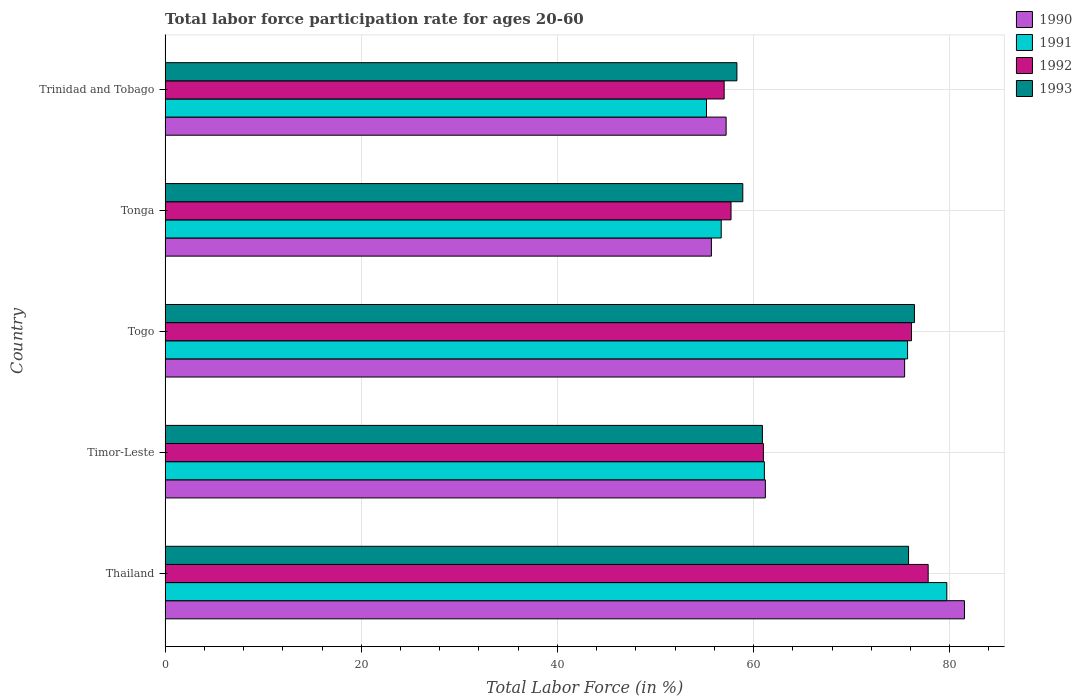Are the number of bars per tick equal to the number of legend labels?
Your response must be concise. Yes. How many bars are there on the 1st tick from the bottom?
Provide a short and direct response. 4. What is the label of the 5th group of bars from the top?
Your answer should be very brief. Thailand. In how many cases, is the number of bars for a given country not equal to the number of legend labels?
Offer a terse response. 0. What is the labor force participation rate in 1993 in Timor-Leste?
Offer a very short reply. 60.9. Across all countries, what is the maximum labor force participation rate in 1992?
Your answer should be very brief. 77.8. Across all countries, what is the minimum labor force participation rate in 1993?
Provide a short and direct response. 58.3. In which country was the labor force participation rate in 1990 maximum?
Your answer should be compact. Thailand. In which country was the labor force participation rate in 1992 minimum?
Your answer should be compact. Trinidad and Tobago. What is the total labor force participation rate in 1992 in the graph?
Provide a short and direct response. 329.6. What is the difference between the labor force participation rate in 1993 in Togo and that in Tonga?
Provide a succinct answer. 17.5. What is the difference between the labor force participation rate in 1992 in Tonga and the labor force participation rate in 1990 in Thailand?
Offer a very short reply. -23.8. What is the average labor force participation rate in 1992 per country?
Provide a short and direct response. 65.92. What is the difference between the labor force participation rate in 1993 and labor force participation rate in 1991 in Tonga?
Your answer should be compact. 2.2. What is the ratio of the labor force participation rate in 1991 in Thailand to that in Trinidad and Tobago?
Make the answer very short. 1.44. Is the difference between the labor force participation rate in 1993 in Timor-Leste and Tonga greater than the difference between the labor force participation rate in 1991 in Timor-Leste and Tonga?
Your response must be concise. No. What is the difference between the highest and the second highest labor force participation rate in 1990?
Offer a terse response. 6.1. What is the difference between the highest and the lowest labor force participation rate in 1990?
Offer a terse response. 25.8. In how many countries, is the labor force participation rate in 1991 greater than the average labor force participation rate in 1991 taken over all countries?
Offer a very short reply. 2. Is it the case that in every country, the sum of the labor force participation rate in 1991 and labor force participation rate in 1993 is greater than the sum of labor force participation rate in 1990 and labor force participation rate in 1992?
Give a very brief answer. No. What does the 2nd bar from the bottom in Timor-Leste represents?
Offer a very short reply. 1991. Is it the case that in every country, the sum of the labor force participation rate in 1990 and labor force participation rate in 1993 is greater than the labor force participation rate in 1991?
Offer a very short reply. Yes. Does the graph contain any zero values?
Ensure brevity in your answer.  No. Does the graph contain grids?
Offer a very short reply. Yes. Where does the legend appear in the graph?
Give a very brief answer. Top right. What is the title of the graph?
Your answer should be compact. Total labor force participation rate for ages 20-60. Does "1974" appear as one of the legend labels in the graph?
Your answer should be compact. No. What is the label or title of the X-axis?
Keep it short and to the point. Total Labor Force (in %). What is the label or title of the Y-axis?
Provide a succinct answer. Country. What is the Total Labor Force (in %) in 1990 in Thailand?
Provide a short and direct response. 81.5. What is the Total Labor Force (in %) of 1991 in Thailand?
Offer a terse response. 79.7. What is the Total Labor Force (in %) in 1992 in Thailand?
Your response must be concise. 77.8. What is the Total Labor Force (in %) of 1993 in Thailand?
Your answer should be compact. 75.8. What is the Total Labor Force (in %) in 1990 in Timor-Leste?
Provide a short and direct response. 61.2. What is the Total Labor Force (in %) in 1991 in Timor-Leste?
Your answer should be compact. 61.1. What is the Total Labor Force (in %) in 1993 in Timor-Leste?
Keep it short and to the point. 60.9. What is the Total Labor Force (in %) in 1990 in Togo?
Provide a short and direct response. 75.4. What is the Total Labor Force (in %) in 1991 in Togo?
Ensure brevity in your answer.  75.7. What is the Total Labor Force (in %) of 1992 in Togo?
Your answer should be very brief. 76.1. What is the Total Labor Force (in %) in 1993 in Togo?
Provide a succinct answer. 76.4. What is the Total Labor Force (in %) in 1990 in Tonga?
Your answer should be compact. 55.7. What is the Total Labor Force (in %) of 1991 in Tonga?
Offer a terse response. 56.7. What is the Total Labor Force (in %) in 1992 in Tonga?
Make the answer very short. 57.7. What is the Total Labor Force (in %) of 1993 in Tonga?
Your answer should be compact. 58.9. What is the Total Labor Force (in %) of 1990 in Trinidad and Tobago?
Ensure brevity in your answer.  57.2. What is the Total Labor Force (in %) in 1991 in Trinidad and Tobago?
Your answer should be compact. 55.2. What is the Total Labor Force (in %) of 1992 in Trinidad and Tobago?
Ensure brevity in your answer.  57. What is the Total Labor Force (in %) of 1993 in Trinidad and Tobago?
Provide a succinct answer. 58.3. Across all countries, what is the maximum Total Labor Force (in %) in 1990?
Make the answer very short. 81.5. Across all countries, what is the maximum Total Labor Force (in %) in 1991?
Make the answer very short. 79.7. Across all countries, what is the maximum Total Labor Force (in %) of 1992?
Your answer should be compact. 77.8. Across all countries, what is the maximum Total Labor Force (in %) of 1993?
Make the answer very short. 76.4. Across all countries, what is the minimum Total Labor Force (in %) in 1990?
Offer a very short reply. 55.7. Across all countries, what is the minimum Total Labor Force (in %) in 1991?
Your response must be concise. 55.2. Across all countries, what is the minimum Total Labor Force (in %) of 1992?
Your answer should be very brief. 57. Across all countries, what is the minimum Total Labor Force (in %) in 1993?
Provide a short and direct response. 58.3. What is the total Total Labor Force (in %) in 1990 in the graph?
Your answer should be very brief. 331. What is the total Total Labor Force (in %) in 1991 in the graph?
Offer a terse response. 328.4. What is the total Total Labor Force (in %) in 1992 in the graph?
Keep it short and to the point. 329.6. What is the total Total Labor Force (in %) in 1993 in the graph?
Offer a terse response. 330.3. What is the difference between the Total Labor Force (in %) of 1990 in Thailand and that in Timor-Leste?
Provide a short and direct response. 20.3. What is the difference between the Total Labor Force (in %) in 1992 in Thailand and that in Timor-Leste?
Provide a short and direct response. 16.8. What is the difference between the Total Labor Force (in %) in 1993 in Thailand and that in Timor-Leste?
Make the answer very short. 14.9. What is the difference between the Total Labor Force (in %) of 1990 in Thailand and that in Togo?
Your answer should be very brief. 6.1. What is the difference between the Total Labor Force (in %) of 1991 in Thailand and that in Togo?
Give a very brief answer. 4. What is the difference between the Total Labor Force (in %) of 1992 in Thailand and that in Togo?
Your response must be concise. 1.7. What is the difference between the Total Labor Force (in %) in 1990 in Thailand and that in Tonga?
Your answer should be compact. 25.8. What is the difference between the Total Labor Force (in %) of 1991 in Thailand and that in Tonga?
Your answer should be very brief. 23. What is the difference between the Total Labor Force (in %) of 1992 in Thailand and that in Tonga?
Ensure brevity in your answer.  20.1. What is the difference between the Total Labor Force (in %) in 1990 in Thailand and that in Trinidad and Tobago?
Your response must be concise. 24.3. What is the difference between the Total Labor Force (in %) of 1991 in Thailand and that in Trinidad and Tobago?
Your answer should be compact. 24.5. What is the difference between the Total Labor Force (in %) in 1992 in Thailand and that in Trinidad and Tobago?
Keep it short and to the point. 20.8. What is the difference between the Total Labor Force (in %) of 1990 in Timor-Leste and that in Togo?
Your answer should be compact. -14.2. What is the difference between the Total Labor Force (in %) of 1991 in Timor-Leste and that in Togo?
Your answer should be very brief. -14.6. What is the difference between the Total Labor Force (in %) of 1992 in Timor-Leste and that in Togo?
Your response must be concise. -15.1. What is the difference between the Total Labor Force (in %) in 1993 in Timor-Leste and that in Togo?
Your answer should be very brief. -15.5. What is the difference between the Total Labor Force (in %) of 1991 in Timor-Leste and that in Tonga?
Offer a terse response. 4.4. What is the difference between the Total Labor Force (in %) of 1990 in Timor-Leste and that in Trinidad and Tobago?
Provide a short and direct response. 4. What is the difference between the Total Labor Force (in %) of 1990 in Togo and that in Tonga?
Offer a terse response. 19.7. What is the difference between the Total Labor Force (in %) of 1990 in Togo and that in Trinidad and Tobago?
Keep it short and to the point. 18.2. What is the difference between the Total Labor Force (in %) in 1990 in Thailand and the Total Labor Force (in %) in 1991 in Timor-Leste?
Offer a terse response. 20.4. What is the difference between the Total Labor Force (in %) of 1990 in Thailand and the Total Labor Force (in %) of 1992 in Timor-Leste?
Offer a very short reply. 20.5. What is the difference between the Total Labor Force (in %) in 1990 in Thailand and the Total Labor Force (in %) in 1993 in Timor-Leste?
Your answer should be very brief. 20.6. What is the difference between the Total Labor Force (in %) of 1991 in Thailand and the Total Labor Force (in %) of 1992 in Timor-Leste?
Make the answer very short. 18.7. What is the difference between the Total Labor Force (in %) of 1990 in Thailand and the Total Labor Force (in %) of 1992 in Togo?
Make the answer very short. 5.4. What is the difference between the Total Labor Force (in %) of 1991 in Thailand and the Total Labor Force (in %) of 1992 in Togo?
Your answer should be very brief. 3.6. What is the difference between the Total Labor Force (in %) in 1991 in Thailand and the Total Labor Force (in %) in 1993 in Togo?
Offer a terse response. 3.3. What is the difference between the Total Labor Force (in %) in 1992 in Thailand and the Total Labor Force (in %) in 1993 in Togo?
Offer a terse response. 1.4. What is the difference between the Total Labor Force (in %) of 1990 in Thailand and the Total Labor Force (in %) of 1991 in Tonga?
Provide a short and direct response. 24.8. What is the difference between the Total Labor Force (in %) in 1990 in Thailand and the Total Labor Force (in %) in 1992 in Tonga?
Offer a very short reply. 23.8. What is the difference between the Total Labor Force (in %) of 1990 in Thailand and the Total Labor Force (in %) of 1993 in Tonga?
Give a very brief answer. 22.6. What is the difference between the Total Labor Force (in %) in 1991 in Thailand and the Total Labor Force (in %) in 1992 in Tonga?
Ensure brevity in your answer.  22. What is the difference between the Total Labor Force (in %) of 1991 in Thailand and the Total Labor Force (in %) of 1993 in Tonga?
Your answer should be compact. 20.8. What is the difference between the Total Labor Force (in %) of 1992 in Thailand and the Total Labor Force (in %) of 1993 in Tonga?
Your answer should be compact. 18.9. What is the difference between the Total Labor Force (in %) of 1990 in Thailand and the Total Labor Force (in %) of 1991 in Trinidad and Tobago?
Provide a short and direct response. 26.3. What is the difference between the Total Labor Force (in %) in 1990 in Thailand and the Total Labor Force (in %) in 1992 in Trinidad and Tobago?
Offer a terse response. 24.5. What is the difference between the Total Labor Force (in %) of 1990 in Thailand and the Total Labor Force (in %) of 1993 in Trinidad and Tobago?
Your response must be concise. 23.2. What is the difference between the Total Labor Force (in %) in 1991 in Thailand and the Total Labor Force (in %) in 1992 in Trinidad and Tobago?
Your answer should be very brief. 22.7. What is the difference between the Total Labor Force (in %) of 1991 in Thailand and the Total Labor Force (in %) of 1993 in Trinidad and Tobago?
Provide a succinct answer. 21.4. What is the difference between the Total Labor Force (in %) of 1990 in Timor-Leste and the Total Labor Force (in %) of 1991 in Togo?
Offer a very short reply. -14.5. What is the difference between the Total Labor Force (in %) of 1990 in Timor-Leste and the Total Labor Force (in %) of 1992 in Togo?
Your answer should be compact. -14.9. What is the difference between the Total Labor Force (in %) in 1990 in Timor-Leste and the Total Labor Force (in %) in 1993 in Togo?
Keep it short and to the point. -15.2. What is the difference between the Total Labor Force (in %) of 1991 in Timor-Leste and the Total Labor Force (in %) of 1993 in Togo?
Provide a short and direct response. -15.3. What is the difference between the Total Labor Force (in %) of 1992 in Timor-Leste and the Total Labor Force (in %) of 1993 in Togo?
Your answer should be compact. -15.4. What is the difference between the Total Labor Force (in %) of 1990 in Timor-Leste and the Total Labor Force (in %) of 1992 in Tonga?
Offer a very short reply. 3.5. What is the difference between the Total Labor Force (in %) in 1991 in Timor-Leste and the Total Labor Force (in %) in 1992 in Tonga?
Offer a very short reply. 3.4. What is the difference between the Total Labor Force (in %) of 1991 in Timor-Leste and the Total Labor Force (in %) of 1993 in Tonga?
Ensure brevity in your answer.  2.2. What is the difference between the Total Labor Force (in %) in 1990 in Timor-Leste and the Total Labor Force (in %) in 1992 in Trinidad and Tobago?
Make the answer very short. 4.2. What is the difference between the Total Labor Force (in %) in 1992 in Timor-Leste and the Total Labor Force (in %) in 1993 in Trinidad and Tobago?
Keep it short and to the point. 2.7. What is the difference between the Total Labor Force (in %) of 1990 in Togo and the Total Labor Force (in %) of 1993 in Tonga?
Give a very brief answer. 16.5. What is the difference between the Total Labor Force (in %) in 1991 in Togo and the Total Labor Force (in %) in 1993 in Tonga?
Give a very brief answer. 16.8. What is the difference between the Total Labor Force (in %) in 1992 in Togo and the Total Labor Force (in %) in 1993 in Tonga?
Your answer should be compact. 17.2. What is the difference between the Total Labor Force (in %) of 1990 in Togo and the Total Labor Force (in %) of 1991 in Trinidad and Tobago?
Offer a very short reply. 20.2. What is the difference between the Total Labor Force (in %) of 1990 in Togo and the Total Labor Force (in %) of 1992 in Trinidad and Tobago?
Your answer should be very brief. 18.4. What is the difference between the Total Labor Force (in %) in 1991 in Togo and the Total Labor Force (in %) in 1993 in Trinidad and Tobago?
Your answer should be compact. 17.4. What is the difference between the Total Labor Force (in %) of 1990 in Tonga and the Total Labor Force (in %) of 1991 in Trinidad and Tobago?
Your response must be concise. 0.5. What is the difference between the Total Labor Force (in %) of 1991 in Tonga and the Total Labor Force (in %) of 1992 in Trinidad and Tobago?
Keep it short and to the point. -0.3. What is the difference between the Total Labor Force (in %) of 1991 in Tonga and the Total Labor Force (in %) of 1993 in Trinidad and Tobago?
Your answer should be very brief. -1.6. What is the difference between the Total Labor Force (in %) of 1992 in Tonga and the Total Labor Force (in %) of 1993 in Trinidad and Tobago?
Keep it short and to the point. -0.6. What is the average Total Labor Force (in %) of 1990 per country?
Your response must be concise. 66.2. What is the average Total Labor Force (in %) in 1991 per country?
Keep it short and to the point. 65.68. What is the average Total Labor Force (in %) of 1992 per country?
Provide a short and direct response. 65.92. What is the average Total Labor Force (in %) in 1993 per country?
Provide a succinct answer. 66.06. What is the difference between the Total Labor Force (in %) of 1990 and Total Labor Force (in %) of 1992 in Thailand?
Offer a very short reply. 3.7. What is the difference between the Total Labor Force (in %) of 1991 and Total Labor Force (in %) of 1993 in Thailand?
Provide a succinct answer. 3.9. What is the difference between the Total Labor Force (in %) in 1992 and Total Labor Force (in %) in 1993 in Thailand?
Your answer should be very brief. 2. What is the difference between the Total Labor Force (in %) in 1990 and Total Labor Force (in %) in 1991 in Timor-Leste?
Your response must be concise. 0.1. What is the difference between the Total Labor Force (in %) in 1990 and Total Labor Force (in %) in 1993 in Timor-Leste?
Offer a very short reply. 0.3. What is the difference between the Total Labor Force (in %) of 1991 and Total Labor Force (in %) of 1992 in Timor-Leste?
Your response must be concise. 0.1. What is the difference between the Total Labor Force (in %) of 1991 and Total Labor Force (in %) of 1993 in Timor-Leste?
Your answer should be very brief. 0.2. What is the difference between the Total Labor Force (in %) in 1992 and Total Labor Force (in %) in 1993 in Timor-Leste?
Your answer should be compact. 0.1. What is the difference between the Total Labor Force (in %) in 1990 and Total Labor Force (in %) in 1992 in Togo?
Provide a short and direct response. -0.7. What is the difference between the Total Labor Force (in %) in 1990 and Total Labor Force (in %) in 1993 in Togo?
Offer a terse response. -1. What is the difference between the Total Labor Force (in %) in 1991 and Total Labor Force (in %) in 1993 in Togo?
Offer a very short reply. -0.7. What is the difference between the Total Labor Force (in %) of 1990 and Total Labor Force (in %) of 1991 in Tonga?
Make the answer very short. -1. What is the difference between the Total Labor Force (in %) in 1990 and Total Labor Force (in %) in 1992 in Tonga?
Keep it short and to the point. -2. What is the difference between the Total Labor Force (in %) in 1990 and Total Labor Force (in %) in 1993 in Tonga?
Your answer should be very brief. -3.2. What is the difference between the Total Labor Force (in %) in 1990 and Total Labor Force (in %) in 1991 in Trinidad and Tobago?
Ensure brevity in your answer.  2. What is the difference between the Total Labor Force (in %) of 1990 and Total Labor Force (in %) of 1992 in Trinidad and Tobago?
Provide a succinct answer. 0.2. What is the difference between the Total Labor Force (in %) in 1990 and Total Labor Force (in %) in 1993 in Trinidad and Tobago?
Give a very brief answer. -1.1. What is the difference between the Total Labor Force (in %) in 1991 and Total Labor Force (in %) in 1992 in Trinidad and Tobago?
Make the answer very short. -1.8. What is the difference between the Total Labor Force (in %) in 1992 and Total Labor Force (in %) in 1993 in Trinidad and Tobago?
Your answer should be compact. -1.3. What is the ratio of the Total Labor Force (in %) of 1990 in Thailand to that in Timor-Leste?
Your response must be concise. 1.33. What is the ratio of the Total Labor Force (in %) of 1991 in Thailand to that in Timor-Leste?
Provide a short and direct response. 1.3. What is the ratio of the Total Labor Force (in %) of 1992 in Thailand to that in Timor-Leste?
Make the answer very short. 1.28. What is the ratio of the Total Labor Force (in %) in 1993 in Thailand to that in Timor-Leste?
Your answer should be compact. 1.24. What is the ratio of the Total Labor Force (in %) in 1990 in Thailand to that in Togo?
Provide a succinct answer. 1.08. What is the ratio of the Total Labor Force (in %) of 1991 in Thailand to that in Togo?
Make the answer very short. 1.05. What is the ratio of the Total Labor Force (in %) of 1992 in Thailand to that in Togo?
Your answer should be very brief. 1.02. What is the ratio of the Total Labor Force (in %) in 1990 in Thailand to that in Tonga?
Offer a very short reply. 1.46. What is the ratio of the Total Labor Force (in %) of 1991 in Thailand to that in Tonga?
Keep it short and to the point. 1.41. What is the ratio of the Total Labor Force (in %) in 1992 in Thailand to that in Tonga?
Give a very brief answer. 1.35. What is the ratio of the Total Labor Force (in %) of 1993 in Thailand to that in Tonga?
Make the answer very short. 1.29. What is the ratio of the Total Labor Force (in %) of 1990 in Thailand to that in Trinidad and Tobago?
Offer a terse response. 1.42. What is the ratio of the Total Labor Force (in %) of 1991 in Thailand to that in Trinidad and Tobago?
Offer a terse response. 1.44. What is the ratio of the Total Labor Force (in %) in 1992 in Thailand to that in Trinidad and Tobago?
Offer a terse response. 1.36. What is the ratio of the Total Labor Force (in %) in 1993 in Thailand to that in Trinidad and Tobago?
Your response must be concise. 1.3. What is the ratio of the Total Labor Force (in %) in 1990 in Timor-Leste to that in Togo?
Make the answer very short. 0.81. What is the ratio of the Total Labor Force (in %) in 1991 in Timor-Leste to that in Togo?
Make the answer very short. 0.81. What is the ratio of the Total Labor Force (in %) in 1992 in Timor-Leste to that in Togo?
Your answer should be very brief. 0.8. What is the ratio of the Total Labor Force (in %) in 1993 in Timor-Leste to that in Togo?
Offer a terse response. 0.8. What is the ratio of the Total Labor Force (in %) in 1990 in Timor-Leste to that in Tonga?
Ensure brevity in your answer.  1.1. What is the ratio of the Total Labor Force (in %) in 1991 in Timor-Leste to that in Tonga?
Provide a succinct answer. 1.08. What is the ratio of the Total Labor Force (in %) of 1992 in Timor-Leste to that in Tonga?
Provide a short and direct response. 1.06. What is the ratio of the Total Labor Force (in %) in 1993 in Timor-Leste to that in Tonga?
Provide a short and direct response. 1.03. What is the ratio of the Total Labor Force (in %) in 1990 in Timor-Leste to that in Trinidad and Tobago?
Make the answer very short. 1.07. What is the ratio of the Total Labor Force (in %) of 1991 in Timor-Leste to that in Trinidad and Tobago?
Your response must be concise. 1.11. What is the ratio of the Total Labor Force (in %) of 1992 in Timor-Leste to that in Trinidad and Tobago?
Your answer should be compact. 1.07. What is the ratio of the Total Labor Force (in %) in 1993 in Timor-Leste to that in Trinidad and Tobago?
Offer a terse response. 1.04. What is the ratio of the Total Labor Force (in %) in 1990 in Togo to that in Tonga?
Ensure brevity in your answer.  1.35. What is the ratio of the Total Labor Force (in %) in 1991 in Togo to that in Tonga?
Your answer should be very brief. 1.34. What is the ratio of the Total Labor Force (in %) of 1992 in Togo to that in Tonga?
Your response must be concise. 1.32. What is the ratio of the Total Labor Force (in %) in 1993 in Togo to that in Tonga?
Offer a very short reply. 1.3. What is the ratio of the Total Labor Force (in %) of 1990 in Togo to that in Trinidad and Tobago?
Your response must be concise. 1.32. What is the ratio of the Total Labor Force (in %) in 1991 in Togo to that in Trinidad and Tobago?
Provide a succinct answer. 1.37. What is the ratio of the Total Labor Force (in %) of 1992 in Togo to that in Trinidad and Tobago?
Provide a short and direct response. 1.34. What is the ratio of the Total Labor Force (in %) of 1993 in Togo to that in Trinidad and Tobago?
Keep it short and to the point. 1.31. What is the ratio of the Total Labor Force (in %) of 1990 in Tonga to that in Trinidad and Tobago?
Make the answer very short. 0.97. What is the ratio of the Total Labor Force (in %) of 1991 in Tonga to that in Trinidad and Tobago?
Your response must be concise. 1.03. What is the ratio of the Total Labor Force (in %) of 1992 in Tonga to that in Trinidad and Tobago?
Your answer should be compact. 1.01. What is the ratio of the Total Labor Force (in %) of 1993 in Tonga to that in Trinidad and Tobago?
Offer a very short reply. 1.01. What is the difference between the highest and the second highest Total Labor Force (in %) in 1990?
Your answer should be very brief. 6.1. What is the difference between the highest and the second highest Total Labor Force (in %) in 1991?
Ensure brevity in your answer.  4. What is the difference between the highest and the second highest Total Labor Force (in %) of 1992?
Offer a very short reply. 1.7. What is the difference between the highest and the lowest Total Labor Force (in %) of 1990?
Provide a short and direct response. 25.8. What is the difference between the highest and the lowest Total Labor Force (in %) of 1991?
Provide a short and direct response. 24.5. What is the difference between the highest and the lowest Total Labor Force (in %) of 1992?
Make the answer very short. 20.8. 